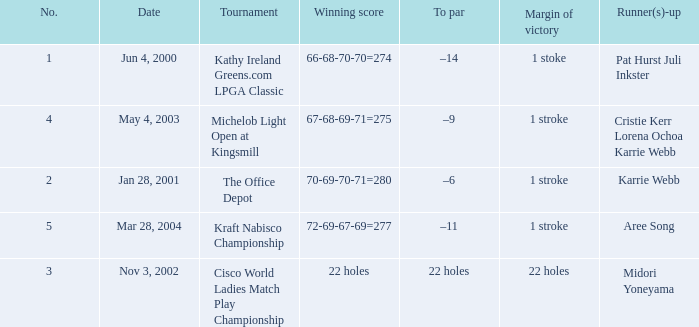What date were the runner ups pat hurst juli inkster? Jun 4, 2000. 